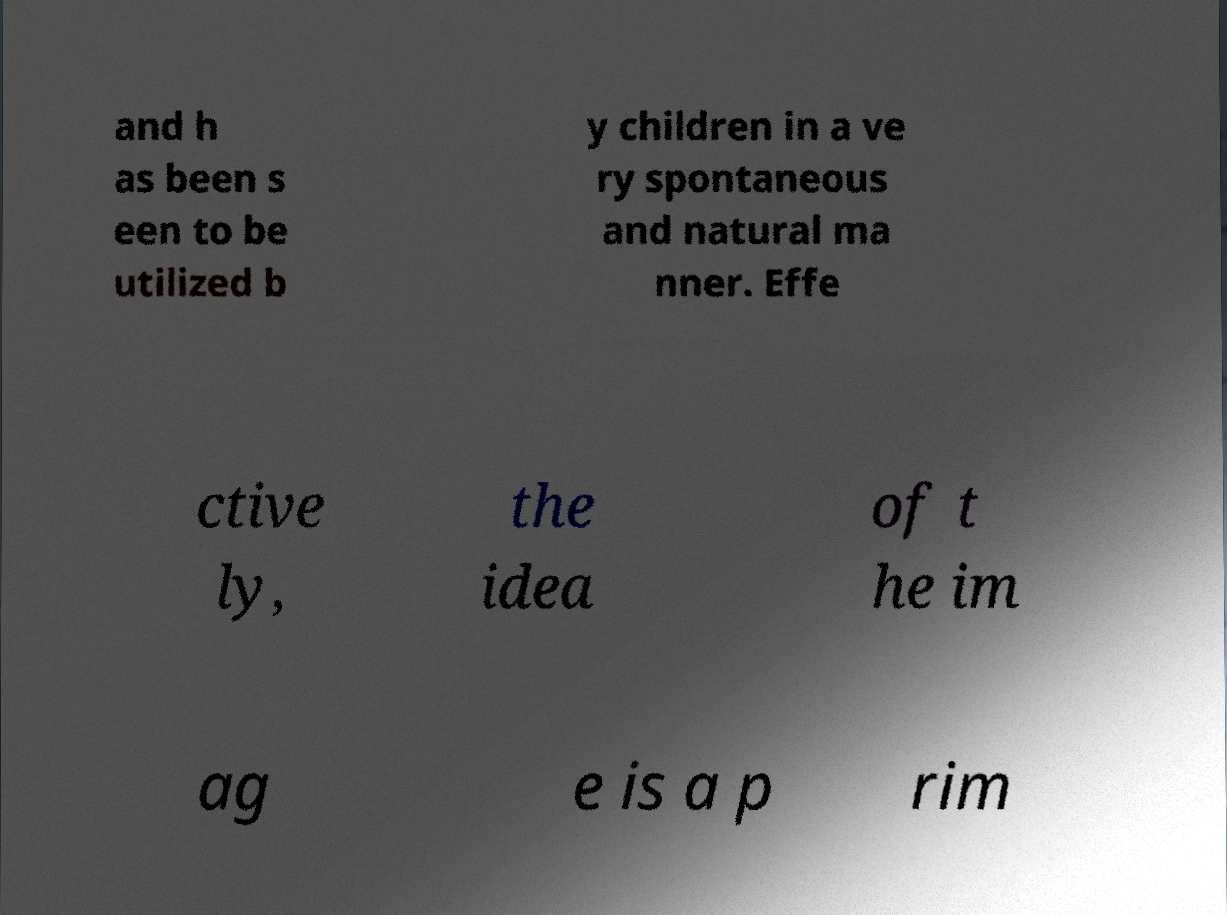Can you accurately transcribe the text from the provided image for me? and h as been s een to be utilized b y children in a ve ry spontaneous and natural ma nner. Effe ctive ly, the idea of t he im ag e is a p rim 